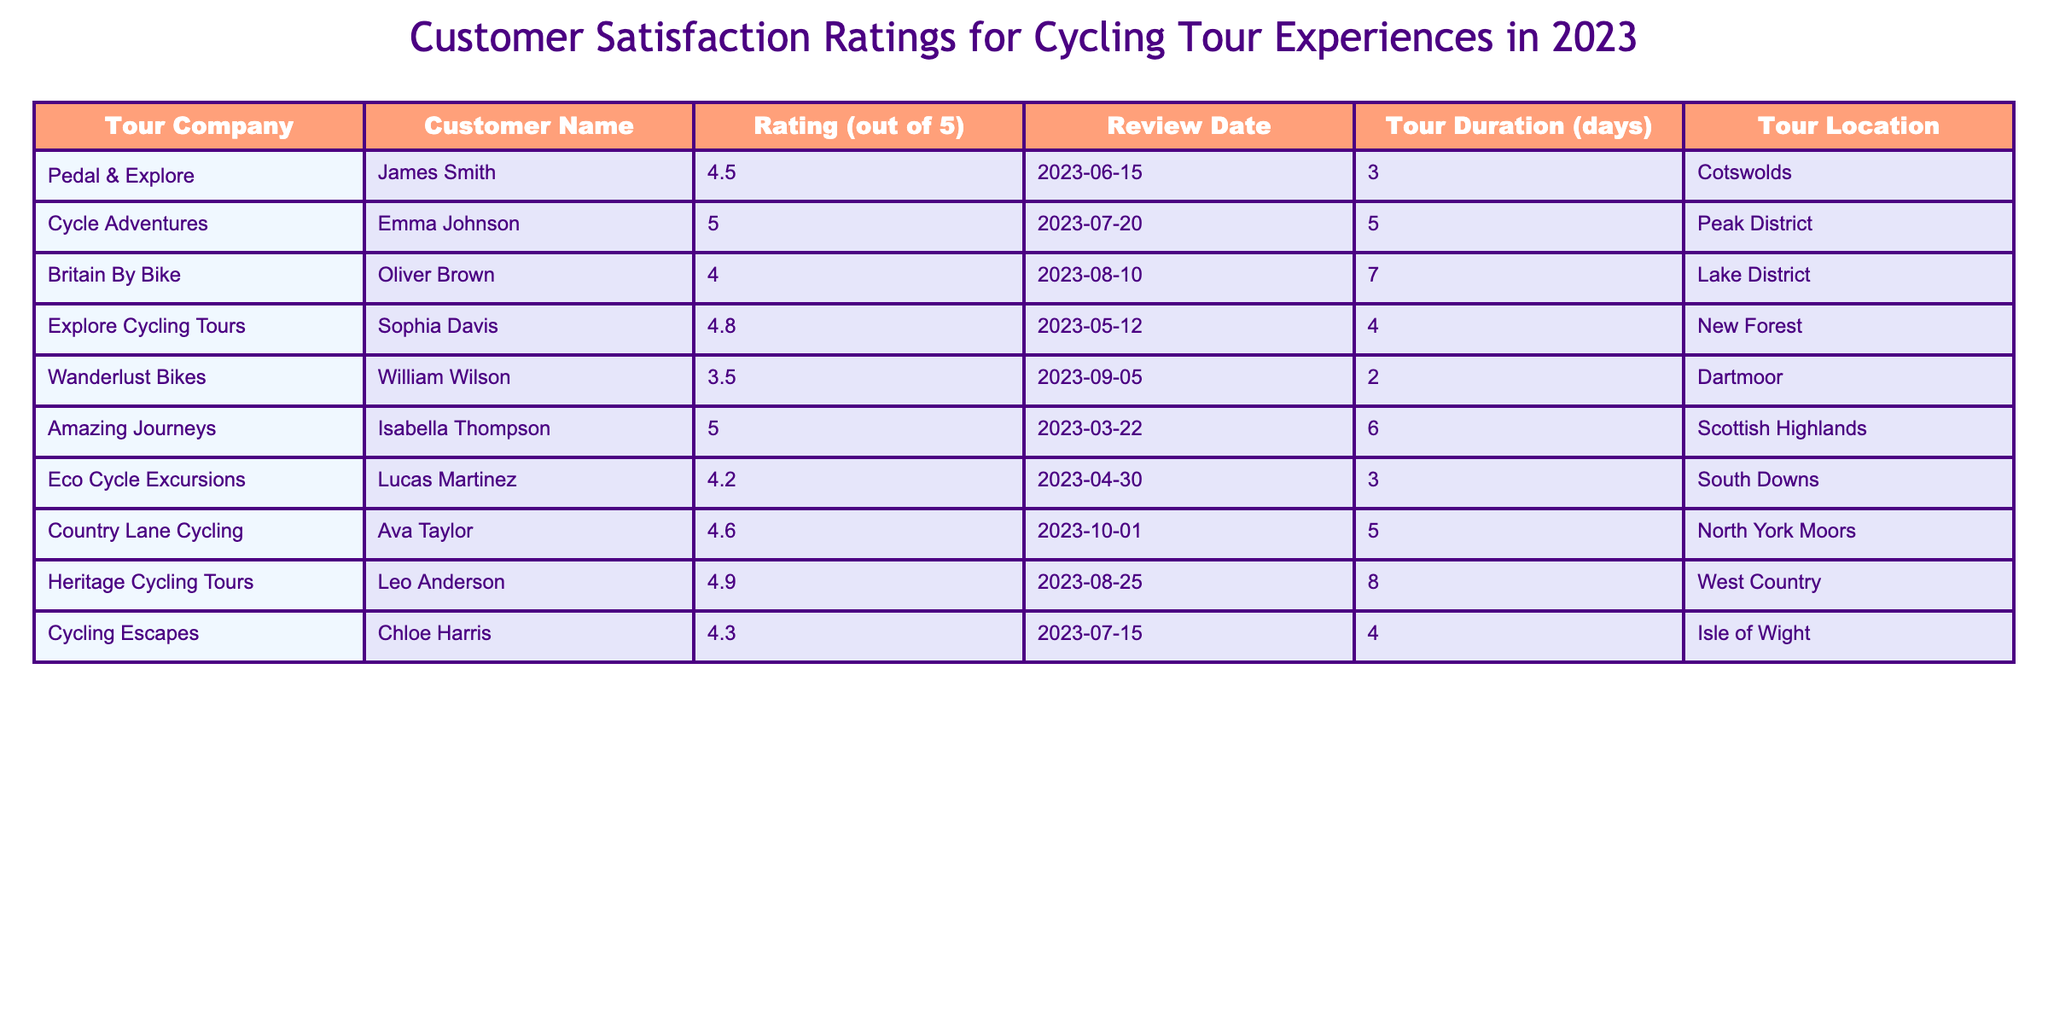What was the highest customer satisfaction rating recorded in 2023? The table lists the ratings, and inspecting the values, the highest one is 5, achieved by Emma Johnson from Cycle Adventures and Isabella Thompson from Amazing Journeys.
Answer: 5 How many days was the shortest cycling tour mentioned in the table? From the duration column in the table, the shortest tour is listed as 2 days, provided by Wanderlust Bikes.
Answer: 2 days Which tour location received an average rating above 4.5? Evaluating the ratings for each tour location, the New Forest, Scottish Highlands, North York Moors, and West Country received ratings above 4.5.
Answer: New Forest, Scottish Highlands, North York Moors, West Country What is the average customer satisfaction rating from the table? To calculate the average rating, add all ratings (4.5 + 5 + 4.0 + 4.8 + 3.5 + 5 + 4.2 + 4.6 + 4.9 + 4.3), which gives a total of 46.5. Then divide by the number of customers (10), resulting in an average of 4.65.
Answer: 4.65 Did any of the cycling tours last more than 6 days? By examining the duration column, both the Lake District (7 days) and Scottish Highlands (6 days) exceed 6 days.
Answer: Yes What percentage of customers rated their experience as 5? There are 10 total ratings, with 2 ratings at 5. The percentage is calculated as (2/10) * 100 = 20%.
Answer: 20% Which tour company had the lowest satisfaction rating? The lowest rating is 3.5 from Wanderlust Bikes, as noted in the ratings column.
Answer: Wanderlust Bikes If you consider only the top three rated tours, what is their combined duration in days? The top three ratings are from Amazing Journeys (6 days), Cycle Adventures (5 days), and Heritage Cycling Tours (8 days). The combined duration is 6 + 5 + 8 = 19 days.
Answer: 19 days Which tour company had a tour duration of 4 days and what was the rating? The company with a 4-day tour is Explore Cycling Tours, which received a rating of 4.8.
Answer: Explore Cycling Tours, 4.8 If a new customer wanted to visit one of the better-rated tours lasting 5 days, which tour should they choose based on this table? Examining the table, Cycle Adventures (rated 5) and Country Lane Cycling (rated 4.6) both offer 5-day tours, but Cycle Adventures has the highest rating of 5.
Answer: Cycle Adventures 